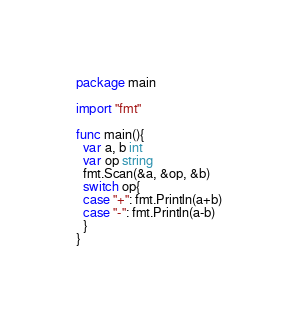Convert code to text. <code><loc_0><loc_0><loc_500><loc_500><_Go_>package main

import "fmt"

func main(){
  var a, b int
  var op string
  fmt.Scan(&a, &op, &b)
  switch op{
  case "+": fmt.Println(a+b)
  case "-": fmt.Println(a-b)
  }
}</code> 